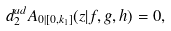Convert formula to latex. <formula><loc_0><loc_0><loc_500><loc_500>d _ { 2 } ^ { a d } A _ { 0 | [ 0 , k _ { 1 } ] } ( z | f , g , h ) = 0 ,</formula> 